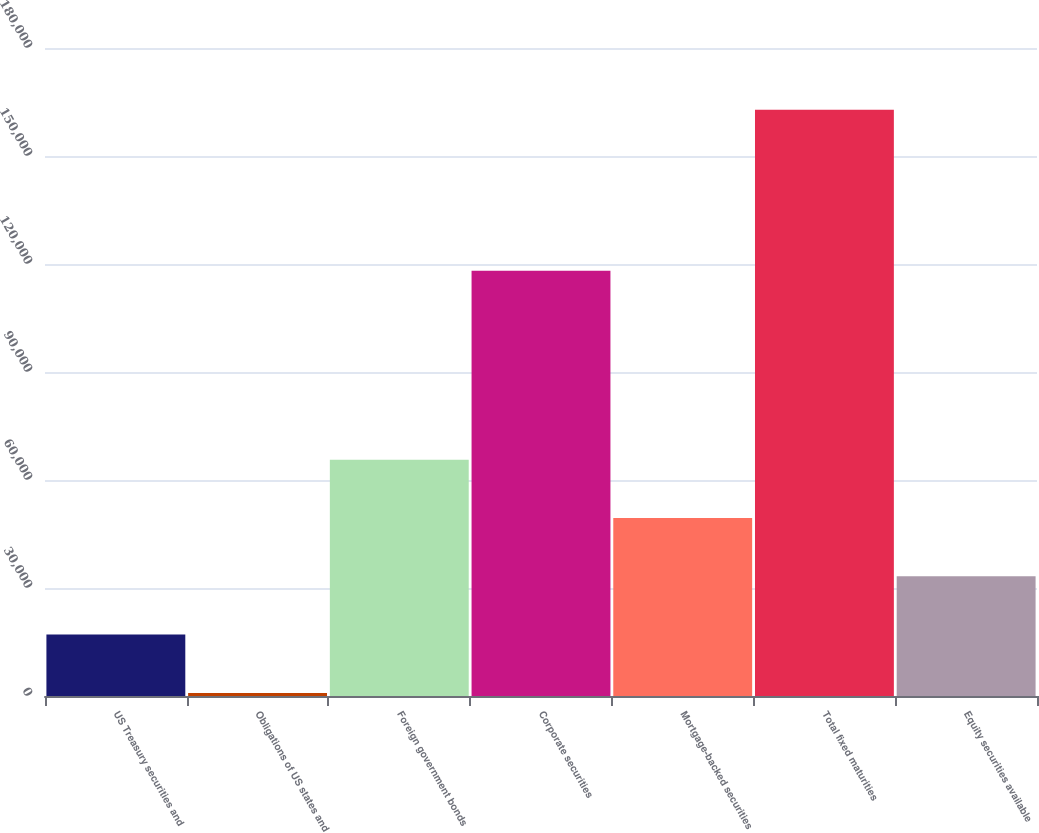Convert chart to OTSL. <chart><loc_0><loc_0><loc_500><loc_500><bar_chart><fcel>US Treasury securities and<fcel>Obligations of US states and<fcel>Foreign government bonds<fcel>Corporate securities<fcel>Mortgage-backed securities<fcel>Total fixed maturities<fcel>Equity securities available<nl><fcel>17058.3<fcel>863<fcel>65644.2<fcel>118149<fcel>49448.9<fcel>162816<fcel>33253.6<nl></chart> 